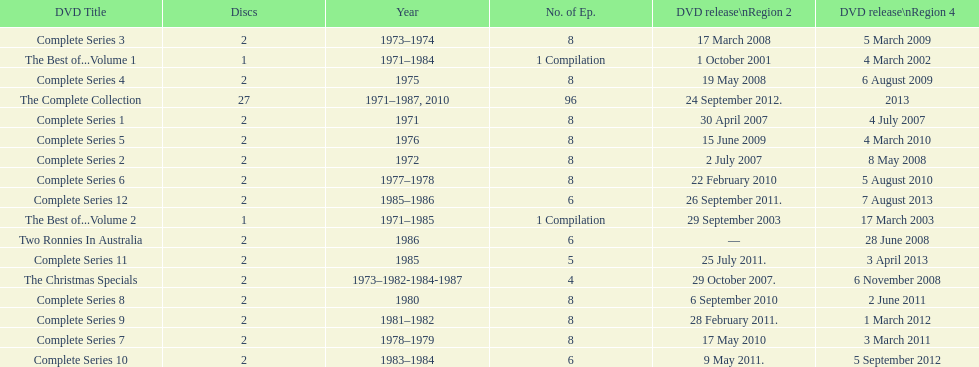How many series had 8 installments? 9. 